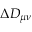<formula> <loc_0><loc_0><loc_500><loc_500>\Delta D _ { \mu \nu }</formula> 